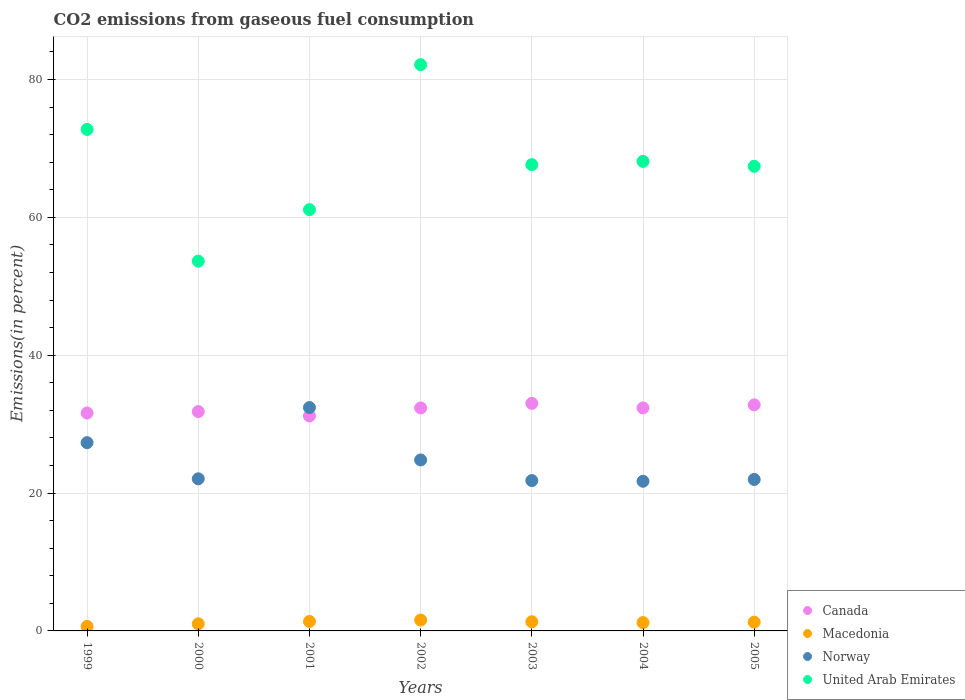How many different coloured dotlines are there?
Offer a very short reply. 4. Is the number of dotlines equal to the number of legend labels?
Keep it short and to the point. Yes. What is the total CO2 emitted in Canada in 2003?
Offer a very short reply. 33.01. Across all years, what is the maximum total CO2 emitted in Norway?
Keep it short and to the point. 32.41. Across all years, what is the minimum total CO2 emitted in Norway?
Keep it short and to the point. 21.71. In which year was the total CO2 emitted in Macedonia maximum?
Offer a very short reply. 2002. In which year was the total CO2 emitted in Macedonia minimum?
Ensure brevity in your answer.  1999. What is the total total CO2 emitted in Canada in the graph?
Your answer should be compact. 225.12. What is the difference between the total CO2 emitted in Macedonia in 1999 and that in 2005?
Make the answer very short. -0.61. What is the difference between the total CO2 emitted in Norway in 2003 and the total CO2 emitted in United Arab Emirates in 1999?
Offer a terse response. -50.95. What is the average total CO2 emitted in Canada per year?
Provide a short and direct response. 32.16. In the year 1999, what is the difference between the total CO2 emitted in Macedonia and total CO2 emitted in United Arab Emirates?
Offer a very short reply. -72.1. In how many years, is the total CO2 emitted in Canada greater than 68 %?
Offer a terse response. 0. What is the ratio of the total CO2 emitted in Macedonia in 1999 to that in 2000?
Keep it short and to the point. 0.64. What is the difference between the highest and the second highest total CO2 emitted in Norway?
Your answer should be very brief. 5.1. What is the difference between the highest and the lowest total CO2 emitted in Canada?
Your answer should be compact. 1.83. In how many years, is the total CO2 emitted in Canada greater than the average total CO2 emitted in Canada taken over all years?
Provide a short and direct response. 4. Is the sum of the total CO2 emitted in United Arab Emirates in 1999 and 2003 greater than the maximum total CO2 emitted in Norway across all years?
Keep it short and to the point. Yes. Is it the case that in every year, the sum of the total CO2 emitted in Norway and total CO2 emitted in Canada  is greater than the sum of total CO2 emitted in Macedonia and total CO2 emitted in United Arab Emirates?
Your response must be concise. No. Is the total CO2 emitted in Canada strictly greater than the total CO2 emitted in Macedonia over the years?
Offer a very short reply. Yes. How many years are there in the graph?
Make the answer very short. 7. Are the values on the major ticks of Y-axis written in scientific E-notation?
Provide a short and direct response. No. Where does the legend appear in the graph?
Offer a very short reply. Bottom right. How many legend labels are there?
Offer a very short reply. 4. What is the title of the graph?
Your response must be concise. CO2 emissions from gaseous fuel consumption. What is the label or title of the Y-axis?
Offer a very short reply. Emissions(in percent). What is the Emissions(in percent) of Canada in 1999?
Offer a terse response. 31.61. What is the Emissions(in percent) in Macedonia in 1999?
Offer a terse response. 0.66. What is the Emissions(in percent) of Norway in 1999?
Offer a very short reply. 27.31. What is the Emissions(in percent) in United Arab Emirates in 1999?
Ensure brevity in your answer.  72.76. What is the Emissions(in percent) of Canada in 2000?
Your response must be concise. 31.82. What is the Emissions(in percent) in Macedonia in 2000?
Make the answer very short. 1.03. What is the Emissions(in percent) in Norway in 2000?
Offer a terse response. 22.07. What is the Emissions(in percent) in United Arab Emirates in 2000?
Offer a very short reply. 53.64. What is the Emissions(in percent) of Canada in 2001?
Your answer should be very brief. 31.18. What is the Emissions(in percent) of Macedonia in 2001?
Offer a very short reply. 1.38. What is the Emissions(in percent) in Norway in 2001?
Your answer should be compact. 32.41. What is the Emissions(in percent) in United Arab Emirates in 2001?
Give a very brief answer. 61.12. What is the Emissions(in percent) of Canada in 2002?
Keep it short and to the point. 32.35. What is the Emissions(in percent) of Macedonia in 2002?
Your answer should be very brief. 1.58. What is the Emissions(in percent) of Norway in 2002?
Provide a short and direct response. 24.8. What is the Emissions(in percent) in United Arab Emirates in 2002?
Your answer should be compact. 82.15. What is the Emissions(in percent) in Canada in 2003?
Offer a terse response. 33.01. What is the Emissions(in percent) in Macedonia in 2003?
Keep it short and to the point. 1.33. What is the Emissions(in percent) in Norway in 2003?
Offer a terse response. 21.81. What is the Emissions(in percent) in United Arab Emirates in 2003?
Your answer should be very brief. 67.64. What is the Emissions(in percent) in Canada in 2004?
Your answer should be compact. 32.35. What is the Emissions(in percent) in Macedonia in 2004?
Offer a very short reply. 1.21. What is the Emissions(in percent) of Norway in 2004?
Your response must be concise. 21.71. What is the Emissions(in percent) in United Arab Emirates in 2004?
Your answer should be compact. 68.12. What is the Emissions(in percent) in Canada in 2005?
Your response must be concise. 32.79. What is the Emissions(in percent) of Macedonia in 2005?
Offer a terse response. 1.27. What is the Emissions(in percent) of Norway in 2005?
Your answer should be very brief. 21.97. What is the Emissions(in percent) of United Arab Emirates in 2005?
Your response must be concise. 67.41. Across all years, what is the maximum Emissions(in percent) in Canada?
Provide a short and direct response. 33.01. Across all years, what is the maximum Emissions(in percent) in Macedonia?
Ensure brevity in your answer.  1.58. Across all years, what is the maximum Emissions(in percent) of Norway?
Ensure brevity in your answer.  32.41. Across all years, what is the maximum Emissions(in percent) in United Arab Emirates?
Your response must be concise. 82.15. Across all years, what is the minimum Emissions(in percent) of Canada?
Keep it short and to the point. 31.18. Across all years, what is the minimum Emissions(in percent) of Macedonia?
Ensure brevity in your answer.  0.66. Across all years, what is the minimum Emissions(in percent) in Norway?
Provide a short and direct response. 21.71. Across all years, what is the minimum Emissions(in percent) of United Arab Emirates?
Your answer should be compact. 53.64. What is the total Emissions(in percent) in Canada in the graph?
Ensure brevity in your answer.  225.12. What is the total Emissions(in percent) of Macedonia in the graph?
Your response must be concise. 8.45. What is the total Emissions(in percent) in Norway in the graph?
Ensure brevity in your answer.  172.09. What is the total Emissions(in percent) of United Arab Emirates in the graph?
Keep it short and to the point. 472.84. What is the difference between the Emissions(in percent) in Canada in 1999 and that in 2000?
Your answer should be compact. -0.21. What is the difference between the Emissions(in percent) in Macedonia in 1999 and that in 2000?
Offer a terse response. -0.38. What is the difference between the Emissions(in percent) in Norway in 1999 and that in 2000?
Make the answer very short. 5.24. What is the difference between the Emissions(in percent) in United Arab Emirates in 1999 and that in 2000?
Your answer should be very brief. 19.12. What is the difference between the Emissions(in percent) in Canada in 1999 and that in 2001?
Give a very brief answer. 0.43. What is the difference between the Emissions(in percent) in Macedonia in 1999 and that in 2001?
Ensure brevity in your answer.  -0.72. What is the difference between the Emissions(in percent) of Norway in 1999 and that in 2001?
Your answer should be compact. -5.1. What is the difference between the Emissions(in percent) in United Arab Emirates in 1999 and that in 2001?
Give a very brief answer. 11.64. What is the difference between the Emissions(in percent) of Canada in 1999 and that in 2002?
Your response must be concise. -0.74. What is the difference between the Emissions(in percent) of Macedonia in 1999 and that in 2002?
Ensure brevity in your answer.  -0.92. What is the difference between the Emissions(in percent) in Norway in 1999 and that in 2002?
Your answer should be compact. 2.51. What is the difference between the Emissions(in percent) of United Arab Emirates in 1999 and that in 2002?
Ensure brevity in your answer.  -9.39. What is the difference between the Emissions(in percent) of Canada in 1999 and that in 2003?
Your answer should be very brief. -1.4. What is the difference between the Emissions(in percent) in Macedonia in 1999 and that in 2003?
Your answer should be compact. -0.67. What is the difference between the Emissions(in percent) of Norway in 1999 and that in 2003?
Provide a short and direct response. 5.5. What is the difference between the Emissions(in percent) in United Arab Emirates in 1999 and that in 2003?
Offer a terse response. 5.12. What is the difference between the Emissions(in percent) in Canada in 1999 and that in 2004?
Your response must be concise. -0.74. What is the difference between the Emissions(in percent) in Macedonia in 1999 and that in 2004?
Give a very brief answer. -0.56. What is the difference between the Emissions(in percent) of Norway in 1999 and that in 2004?
Your answer should be very brief. 5.6. What is the difference between the Emissions(in percent) of United Arab Emirates in 1999 and that in 2004?
Your answer should be very brief. 4.64. What is the difference between the Emissions(in percent) of Canada in 1999 and that in 2005?
Offer a terse response. -1.18. What is the difference between the Emissions(in percent) of Macedonia in 1999 and that in 2005?
Provide a succinct answer. -0.61. What is the difference between the Emissions(in percent) of Norway in 1999 and that in 2005?
Offer a terse response. 5.34. What is the difference between the Emissions(in percent) of United Arab Emirates in 1999 and that in 2005?
Provide a succinct answer. 5.35. What is the difference between the Emissions(in percent) of Canada in 2000 and that in 2001?
Your response must be concise. 0.64. What is the difference between the Emissions(in percent) in Macedonia in 2000 and that in 2001?
Make the answer very short. -0.34. What is the difference between the Emissions(in percent) in Norway in 2000 and that in 2001?
Offer a very short reply. -10.34. What is the difference between the Emissions(in percent) of United Arab Emirates in 2000 and that in 2001?
Your answer should be compact. -7.47. What is the difference between the Emissions(in percent) in Canada in 2000 and that in 2002?
Your response must be concise. -0.53. What is the difference between the Emissions(in percent) of Macedonia in 2000 and that in 2002?
Your answer should be compact. -0.54. What is the difference between the Emissions(in percent) in Norway in 2000 and that in 2002?
Offer a terse response. -2.73. What is the difference between the Emissions(in percent) of United Arab Emirates in 2000 and that in 2002?
Provide a succinct answer. -28.51. What is the difference between the Emissions(in percent) of Canada in 2000 and that in 2003?
Provide a succinct answer. -1.19. What is the difference between the Emissions(in percent) of Macedonia in 2000 and that in 2003?
Keep it short and to the point. -0.3. What is the difference between the Emissions(in percent) of Norway in 2000 and that in 2003?
Your answer should be very brief. 0.26. What is the difference between the Emissions(in percent) in United Arab Emirates in 2000 and that in 2003?
Give a very brief answer. -14. What is the difference between the Emissions(in percent) in Canada in 2000 and that in 2004?
Your response must be concise. -0.53. What is the difference between the Emissions(in percent) of Macedonia in 2000 and that in 2004?
Your answer should be compact. -0.18. What is the difference between the Emissions(in percent) in Norway in 2000 and that in 2004?
Your response must be concise. 0.36. What is the difference between the Emissions(in percent) in United Arab Emirates in 2000 and that in 2004?
Your answer should be compact. -14.48. What is the difference between the Emissions(in percent) of Canada in 2000 and that in 2005?
Ensure brevity in your answer.  -0.97. What is the difference between the Emissions(in percent) in Macedonia in 2000 and that in 2005?
Your answer should be very brief. -0.23. What is the difference between the Emissions(in percent) in Norway in 2000 and that in 2005?
Your response must be concise. 0.1. What is the difference between the Emissions(in percent) in United Arab Emirates in 2000 and that in 2005?
Provide a short and direct response. -13.76. What is the difference between the Emissions(in percent) in Canada in 2001 and that in 2002?
Your answer should be very brief. -1.16. What is the difference between the Emissions(in percent) in Macedonia in 2001 and that in 2002?
Your response must be concise. -0.2. What is the difference between the Emissions(in percent) in Norway in 2001 and that in 2002?
Provide a short and direct response. 7.61. What is the difference between the Emissions(in percent) of United Arab Emirates in 2001 and that in 2002?
Offer a terse response. -21.04. What is the difference between the Emissions(in percent) of Canada in 2001 and that in 2003?
Ensure brevity in your answer.  -1.83. What is the difference between the Emissions(in percent) in Macedonia in 2001 and that in 2003?
Your response must be concise. 0.05. What is the difference between the Emissions(in percent) of Norway in 2001 and that in 2003?
Your answer should be very brief. 10.6. What is the difference between the Emissions(in percent) of United Arab Emirates in 2001 and that in 2003?
Your response must be concise. -6.53. What is the difference between the Emissions(in percent) in Canada in 2001 and that in 2004?
Provide a succinct answer. -1.17. What is the difference between the Emissions(in percent) in Macedonia in 2001 and that in 2004?
Ensure brevity in your answer.  0.16. What is the difference between the Emissions(in percent) in Norway in 2001 and that in 2004?
Your answer should be very brief. 10.7. What is the difference between the Emissions(in percent) in United Arab Emirates in 2001 and that in 2004?
Provide a succinct answer. -7. What is the difference between the Emissions(in percent) of Canada in 2001 and that in 2005?
Offer a terse response. -1.61. What is the difference between the Emissions(in percent) in Macedonia in 2001 and that in 2005?
Offer a terse response. 0.11. What is the difference between the Emissions(in percent) in Norway in 2001 and that in 2005?
Provide a succinct answer. 10.44. What is the difference between the Emissions(in percent) of United Arab Emirates in 2001 and that in 2005?
Your response must be concise. -6.29. What is the difference between the Emissions(in percent) in Canada in 2002 and that in 2003?
Make the answer very short. -0.66. What is the difference between the Emissions(in percent) of Macedonia in 2002 and that in 2003?
Ensure brevity in your answer.  0.25. What is the difference between the Emissions(in percent) of Norway in 2002 and that in 2003?
Give a very brief answer. 2.99. What is the difference between the Emissions(in percent) of United Arab Emirates in 2002 and that in 2003?
Keep it short and to the point. 14.51. What is the difference between the Emissions(in percent) of Canada in 2002 and that in 2004?
Offer a terse response. -0.01. What is the difference between the Emissions(in percent) of Macedonia in 2002 and that in 2004?
Ensure brevity in your answer.  0.36. What is the difference between the Emissions(in percent) of Norway in 2002 and that in 2004?
Provide a succinct answer. 3.09. What is the difference between the Emissions(in percent) in United Arab Emirates in 2002 and that in 2004?
Provide a short and direct response. 14.03. What is the difference between the Emissions(in percent) of Canada in 2002 and that in 2005?
Offer a very short reply. -0.45. What is the difference between the Emissions(in percent) in Macedonia in 2002 and that in 2005?
Make the answer very short. 0.31. What is the difference between the Emissions(in percent) of Norway in 2002 and that in 2005?
Make the answer very short. 2.83. What is the difference between the Emissions(in percent) in United Arab Emirates in 2002 and that in 2005?
Make the answer very short. 14.75. What is the difference between the Emissions(in percent) of Canada in 2003 and that in 2004?
Your response must be concise. 0.66. What is the difference between the Emissions(in percent) in Macedonia in 2003 and that in 2004?
Provide a succinct answer. 0.12. What is the difference between the Emissions(in percent) of Norway in 2003 and that in 2004?
Your answer should be compact. 0.1. What is the difference between the Emissions(in percent) of United Arab Emirates in 2003 and that in 2004?
Offer a terse response. -0.47. What is the difference between the Emissions(in percent) of Canada in 2003 and that in 2005?
Offer a very short reply. 0.22. What is the difference between the Emissions(in percent) in Macedonia in 2003 and that in 2005?
Offer a very short reply. 0.06. What is the difference between the Emissions(in percent) in Norway in 2003 and that in 2005?
Give a very brief answer. -0.16. What is the difference between the Emissions(in percent) of United Arab Emirates in 2003 and that in 2005?
Give a very brief answer. 0.24. What is the difference between the Emissions(in percent) of Canada in 2004 and that in 2005?
Your answer should be very brief. -0.44. What is the difference between the Emissions(in percent) in Macedonia in 2004 and that in 2005?
Give a very brief answer. -0.06. What is the difference between the Emissions(in percent) in Norway in 2004 and that in 2005?
Your response must be concise. -0.26. What is the difference between the Emissions(in percent) in United Arab Emirates in 2004 and that in 2005?
Provide a short and direct response. 0.71. What is the difference between the Emissions(in percent) in Canada in 1999 and the Emissions(in percent) in Macedonia in 2000?
Provide a succinct answer. 30.58. What is the difference between the Emissions(in percent) of Canada in 1999 and the Emissions(in percent) of Norway in 2000?
Offer a very short reply. 9.54. What is the difference between the Emissions(in percent) of Canada in 1999 and the Emissions(in percent) of United Arab Emirates in 2000?
Provide a succinct answer. -22.03. What is the difference between the Emissions(in percent) of Macedonia in 1999 and the Emissions(in percent) of Norway in 2000?
Offer a very short reply. -21.41. What is the difference between the Emissions(in percent) in Macedonia in 1999 and the Emissions(in percent) in United Arab Emirates in 2000?
Give a very brief answer. -52.99. What is the difference between the Emissions(in percent) in Norway in 1999 and the Emissions(in percent) in United Arab Emirates in 2000?
Provide a short and direct response. -26.33. What is the difference between the Emissions(in percent) in Canada in 1999 and the Emissions(in percent) in Macedonia in 2001?
Provide a succinct answer. 30.24. What is the difference between the Emissions(in percent) of Canada in 1999 and the Emissions(in percent) of Norway in 2001?
Offer a very short reply. -0.8. What is the difference between the Emissions(in percent) in Canada in 1999 and the Emissions(in percent) in United Arab Emirates in 2001?
Provide a short and direct response. -29.5. What is the difference between the Emissions(in percent) in Macedonia in 1999 and the Emissions(in percent) in Norway in 2001?
Your answer should be very brief. -31.75. What is the difference between the Emissions(in percent) of Macedonia in 1999 and the Emissions(in percent) of United Arab Emirates in 2001?
Your answer should be compact. -60.46. What is the difference between the Emissions(in percent) of Norway in 1999 and the Emissions(in percent) of United Arab Emirates in 2001?
Provide a short and direct response. -33.8. What is the difference between the Emissions(in percent) in Canada in 1999 and the Emissions(in percent) in Macedonia in 2002?
Offer a terse response. 30.04. What is the difference between the Emissions(in percent) of Canada in 1999 and the Emissions(in percent) of Norway in 2002?
Ensure brevity in your answer.  6.81. What is the difference between the Emissions(in percent) in Canada in 1999 and the Emissions(in percent) in United Arab Emirates in 2002?
Provide a succinct answer. -50.54. What is the difference between the Emissions(in percent) in Macedonia in 1999 and the Emissions(in percent) in Norway in 2002?
Your answer should be compact. -24.15. What is the difference between the Emissions(in percent) in Macedonia in 1999 and the Emissions(in percent) in United Arab Emirates in 2002?
Your response must be concise. -81.49. What is the difference between the Emissions(in percent) in Norway in 1999 and the Emissions(in percent) in United Arab Emirates in 2002?
Your response must be concise. -54.84. What is the difference between the Emissions(in percent) of Canada in 1999 and the Emissions(in percent) of Macedonia in 2003?
Your answer should be compact. 30.28. What is the difference between the Emissions(in percent) of Canada in 1999 and the Emissions(in percent) of Norway in 2003?
Your answer should be very brief. 9.8. What is the difference between the Emissions(in percent) of Canada in 1999 and the Emissions(in percent) of United Arab Emirates in 2003?
Your response must be concise. -36.03. What is the difference between the Emissions(in percent) of Macedonia in 1999 and the Emissions(in percent) of Norway in 2003?
Ensure brevity in your answer.  -21.16. What is the difference between the Emissions(in percent) of Macedonia in 1999 and the Emissions(in percent) of United Arab Emirates in 2003?
Offer a very short reply. -66.99. What is the difference between the Emissions(in percent) in Norway in 1999 and the Emissions(in percent) in United Arab Emirates in 2003?
Provide a short and direct response. -40.33. What is the difference between the Emissions(in percent) in Canada in 1999 and the Emissions(in percent) in Macedonia in 2004?
Give a very brief answer. 30.4. What is the difference between the Emissions(in percent) of Canada in 1999 and the Emissions(in percent) of Norway in 2004?
Offer a terse response. 9.9. What is the difference between the Emissions(in percent) of Canada in 1999 and the Emissions(in percent) of United Arab Emirates in 2004?
Offer a very short reply. -36.51. What is the difference between the Emissions(in percent) of Macedonia in 1999 and the Emissions(in percent) of Norway in 2004?
Ensure brevity in your answer.  -21.05. What is the difference between the Emissions(in percent) in Macedonia in 1999 and the Emissions(in percent) in United Arab Emirates in 2004?
Your answer should be compact. -67.46. What is the difference between the Emissions(in percent) of Norway in 1999 and the Emissions(in percent) of United Arab Emirates in 2004?
Provide a short and direct response. -40.81. What is the difference between the Emissions(in percent) of Canada in 1999 and the Emissions(in percent) of Macedonia in 2005?
Offer a terse response. 30.34. What is the difference between the Emissions(in percent) in Canada in 1999 and the Emissions(in percent) in Norway in 2005?
Your response must be concise. 9.64. What is the difference between the Emissions(in percent) in Canada in 1999 and the Emissions(in percent) in United Arab Emirates in 2005?
Your response must be concise. -35.79. What is the difference between the Emissions(in percent) in Macedonia in 1999 and the Emissions(in percent) in Norway in 2005?
Ensure brevity in your answer.  -21.32. What is the difference between the Emissions(in percent) in Macedonia in 1999 and the Emissions(in percent) in United Arab Emirates in 2005?
Provide a succinct answer. -66.75. What is the difference between the Emissions(in percent) of Norway in 1999 and the Emissions(in percent) of United Arab Emirates in 2005?
Give a very brief answer. -40.09. What is the difference between the Emissions(in percent) in Canada in 2000 and the Emissions(in percent) in Macedonia in 2001?
Provide a short and direct response. 30.45. What is the difference between the Emissions(in percent) of Canada in 2000 and the Emissions(in percent) of Norway in 2001?
Offer a terse response. -0.59. What is the difference between the Emissions(in percent) of Canada in 2000 and the Emissions(in percent) of United Arab Emirates in 2001?
Give a very brief answer. -29.29. What is the difference between the Emissions(in percent) of Macedonia in 2000 and the Emissions(in percent) of Norway in 2001?
Give a very brief answer. -31.38. What is the difference between the Emissions(in percent) of Macedonia in 2000 and the Emissions(in percent) of United Arab Emirates in 2001?
Ensure brevity in your answer.  -60.08. What is the difference between the Emissions(in percent) of Norway in 2000 and the Emissions(in percent) of United Arab Emirates in 2001?
Provide a short and direct response. -39.05. What is the difference between the Emissions(in percent) in Canada in 2000 and the Emissions(in percent) in Macedonia in 2002?
Offer a very short reply. 30.24. What is the difference between the Emissions(in percent) of Canada in 2000 and the Emissions(in percent) of Norway in 2002?
Your answer should be very brief. 7.02. What is the difference between the Emissions(in percent) in Canada in 2000 and the Emissions(in percent) in United Arab Emirates in 2002?
Ensure brevity in your answer.  -50.33. What is the difference between the Emissions(in percent) in Macedonia in 2000 and the Emissions(in percent) in Norway in 2002?
Make the answer very short. -23.77. What is the difference between the Emissions(in percent) in Macedonia in 2000 and the Emissions(in percent) in United Arab Emirates in 2002?
Your answer should be very brief. -81.12. What is the difference between the Emissions(in percent) in Norway in 2000 and the Emissions(in percent) in United Arab Emirates in 2002?
Offer a very short reply. -60.08. What is the difference between the Emissions(in percent) in Canada in 2000 and the Emissions(in percent) in Macedonia in 2003?
Provide a succinct answer. 30.49. What is the difference between the Emissions(in percent) of Canada in 2000 and the Emissions(in percent) of Norway in 2003?
Ensure brevity in your answer.  10.01. What is the difference between the Emissions(in percent) of Canada in 2000 and the Emissions(in percent) of United Arab Emirates in 2003?
Your response must be concise. -35.82. What is the difference between the Emissions(in percent) of Macedonia in 2000 and the Emissions(in percent) of Norway in 2003?
Your answer should be very brief. -20.78. What is the difference between the Emissions(in percent) in Macedonia in 2000 and the Emissions(in percent) in United Arab Emirates in 2003?
Your response must be concise. -66.61. What is the difference between the Emissions(in percent) in Norway in 2000 and the Emissions(in percent) in United Arab Emirates in 2003?
Keep it short and to the point. -45.58. What is the difference between the Emissions(in percent) of Canada in 2000 and the Emissions(in percent) of Macedonia in 2004?
Your answer should be compact. 30.61. What is the difference between the Emissions(in percent) in Canada in 2000 and the Emissions(in percent) in Norway in 2004?
Your answer should be very brief. 10.11. What is the difference between the Emissions(in percent) of Canada in 2000 and the Emissions(in percent) of United Arab Emirates in 2004?
Offer a terse response. -36.3. What is the difference between the Emissions(in percent) in Macedonia in 2000 and the Emissions(in percent) in Norway in 2004?
Offer a very short reply. -20.68. What is the difference between the Emissions(in percent) of Macedonia in 2000 and the Emissions(in percent) of United Arab Emirates in 2004?
Give a very brief answer. -67.09. What is the difference between the Emissions(in percent) of Norway in 2000 and the Emissions(in percent) of United Arab Emirates in 2004?
Your answer should be compact. -46.05. What is the difference between the Emissions(in percent) of Canada in 2000 and the Emissions(in percent) of Macedonia in 2005?
Your answer should be very brief. 30.55. What is the difference between the Emissions(in percent) of Canada in 2000 and the Emissions(in percent) of Norway in 2005?
Give a very brief answer. 9.85. What is the difference between the Emissions(in percent) of Canada in 2000 and the Emissions(in percent) of United Arab Emirates in 2005?
Ensure brevity in your answer.  -35.58. What is the difference between the Emissions(in percent) of Macedonia in 2000 and the Emissions(in percent) of Norway in 2005?
Your answer should be compact. -20.94. What is the difference between the Emissions(in percent) of Macedonia in 2000 and the Emissions(in percent) of United Arab Emirates in 2005?
Your answer should be compact. -66.37. What is the difference between the Emissions(in percent) in Norway in 2000 and the Emissions(in percent) in United Arab Emirates in 2005?
Offer a terse response. -45.34. What is the difference between the Emissions(in percent) of Canada in 2001 and the Emissions(in percent) of Macedonia in 2002?
Give a very brief answer. 29.61. What is the difference between the Emissions(in percent) in Canada in 2001 and the Emissions(in percent) in Norway in 2002?
Provide a short and direct response. 6.38. What is the difference between the Emissions(in percent) in Canada in 2001 and the Emissions(in percent) in United Arab Emirates in 2002?
Ensure brevity in your answer.  -50.97. What is the difference between the Emissions(in percent) of Macedonia in 2001 and the Emissions(in percent) of Norway in 2002?
Ensure brevity in your answer.  -23.43. What is the difference between the Emissions(in percent) in Macedonia in 2001 and the Emissions(in percent) in United Arab Emirates in 2002?
Give a very brief answer. -80.78. What is the difference between the Emissions(in percent) in Norway in 2001 and the Emissions(in percent) in United Arab Emirates in 2002?
Your answer should be compact. -49.74. What is the difference between the Emissions(in percent) in Canada in 2001 and the Emissions(in percent) in Macedonia in 2003?
Provide a succinct answer. 29.85. What is the difference between the Emissions(in percent) of Canada in 2001 and the Emissions(in percent) of Norway in 2003?
Make the answer very short. 9.37. What is the difference between the Emissions(in percent) in Canada in 2001 and the Emissions(in percent) in United Arab Emirates in 2003?
Offer a terse response. -36.46. What is the difference between the Emissions(in percent) of Macedonia in 2001 and the Emissions(in percent) of Norway in 2003?
Offer a very short reply. -20.44. What is the difference between the Emissions(in percent) in Macedonia in 2001 and the Emissions(in percent) in United Arab Emirates in 2003?
Ensure brevity in your answer.  -66.27. What is the difference between the Emissions(in percent) of Norway in 2001 and the Emissions(in percent) of United Arab Emirates in 2003?
Offer a very short reply. -35.24. What is the difference between the Emissions(in percent) of Canada in 2001 and the Emissions(in percent) of Macedonia in 2004?
Keep it short and to the point. 29.97. What is the difference between the Emissions(in percent) of Canada in 2001 and the Emissions(in percent) of Norway in 2004?
Offer a terse response. 9.47. What is the difference between the Emissions(in percent) of Canada in 2001 and the Emissions(in percent) of United Arab Emirates in 2004?
Make the answer very short. -36.94. What is the difference between the Emissions(in percent) of Macedonia in 2001 and the Emissions(in percent) of Norway in 2004?
Offer a very short reply. -20.34. What is the difference between the Emissions(in percent) of Macedonia in 2001 and the Emissions(in percent) of United Arab Emirates in 2004?
Offer a very short reply. -66.74. What is the difference between the Emissions(in percent) in Norway in 2001 and the Emissions(in percent) in United Arab Emirates in 2004?
Your answer should be compact. -35.71. What is the difference between the Emissions(in percent) of Canada in 2001 and the Emissions(in percent) of Macedonia in 2005?
Keep it short and to the point. 29.92. What is the difference between the Emissions(in percent) of Canada in 2001 and the Emissions(in percent) of Norway in 2005?
Your response must be concise. 9.21. What is the difference between the Emissions(in percent) of Canada in 2001 and the Emissions(in percent) of United Arab Emirates in 2005?
Provide a short and direct response. -36.22. What is the difference between the Emissions(in percent) of Macedonia in 2001 and the Emissions(in percent) of Norway in 2005?
Provide a succinct answer. -20.6. What is the difference between the Emissions(in percent) in Macedonia in 2001 and the Emissions(in percent) in United Arab Emirates in 2005?
Offer a terse response. -66.03. What is the difference between the Emissions(in percent) of Norway in 2001 and the Emissions(in percent) of United Arab Emirates in 2005?
Your response must be concise. -35. What is the difference between the Emissions(in percent) of Canada in 2002 and the Emissions(in percent) of Macedonia in 2003?
Provide a short and direct response. 31.02. What is the difference between the Emissions(in percent) in Canada in 2002 and the Emissions(in percent) in Norway in 2003?
Make the answer very short. 10.53. What is the difference between the Emissions(in percent) of Canada in 2002 and the Emissions(in percent) of United Arab Emirates in 2003?
Give a very brief answer. -35.3. What is the difference between the Emissions(in percent) in Macedonia in 2002 and the Emissions(in percent) in Norway in 2003?
Give a very brief answer. -20.24. What is the difference between the Emissions(in percent) in Macedonia in 2002 and the Emissions(in percent) in United Arab Emirates in 2003?
Your response must be concise. -66.07. What is the difference between the Emissions(in percent) of Norway in 2002 and the Emissions(in percent) of United Arab Emirates in 2003?
Provide a short and direct response. -42.84. What is the difference between the Emissions(in percent) in Canada in 2002 and the Emissions(in percent) in Macedonia in 2004?
Your response must be concise. 31.14. What is the difference between the Emissions(in percent) in Canada in 2002 and the Emissions(in percent) in Norway in 2004?
Offer a terse response. 10.64. What is the difference between the Emissions(in percent) in Canada in 2002 and the Emissions(in percent) in United Arab Emirates in 2004?
Provide a succinct answer. -35.77. What is the difference between the Emissions(in percent) of Macedonia in 2002 and the Emissions(in percent) of Norway in 2004?
Make the answer very short. -20.14. What is the difference between the Emissions(in percent) of Macedonia in 2002 and the Emissions(in percent) of United Arab Emirates in 2004?
Keep it short and to the point. -66.54. What is the difference between the Emissions(in percent) of Norway in 2002 and the Emissions(in percent) of United Arab Emirates in 2004?
Make the answer very short. -43.32. What is the difference between the Emissions(in percent) in Canada in 2002 and the Emissions(in percent) in Macedonia in 2005?
Keep it short and to the point. 31.08. What is the difference between the Emissions(in percent) in Canada in 2002 and the Emissions(in percent) in Norway in 2005?
Provide a succinct answer. 10.37. What is the difference between the Emissions(in percent) in Canada in 2002 and the Emissions(in percent) in United Arab Emirates in 2005?
Make the answer very short. -35.06. What is the difference between the Emissions(in percent) in Macedonia in 2002 and the Emissions(in percent) in Norway in 2005?
Your response must be concise. -20.4. What is the difference between the Emissions(in percent) in Macedonia in 2002 and the Emissions(in percent) in United Arab Emirates in 2005?
Keep it short and to the point. -65.83. What is the difference between the Emissions(in percent) of Norway in 2002 and the Emissions(in percent) of United Arab Emirates in 2005?
Your answer should be compact. -42.6. What is the difference between the Emissions(in percent) of Canada in 2003 and the Emissions(in percent) of Macedonia in 2004?
Your response must be concise. 31.8. What is the difference between the Emissions(in percent) of Canada in 2003 and the Emissions(in percent) of Norway in 2004?
Ensure brevity in your answer.  11.3. What is the difference between the Emissions(in percent) in Canada in 2003 and the Emissions(in percent) in United Arab Emirates in 2004?
Make the answer very short. -35.11. What is the difference between the Emissions(in percent) of Macedonia in 2003 and the Emissions(in percent) of Norway in 2004?
Provide a succinct answer. -20.38. What is the difference between the Emissions(in percent) of Macedonia in 2003 and the Emissions(in percent) of United Arab Emirates in 2004?
Ensure brevity in your answer.  -66.79. What is the difference between the Emissions(in percent) in Norway in 2003 and the Emissions(in percent) in United Arab Emirates in 2004?
Offer a terse response. -46.31. What is the difference between the Emissions(in percent) of Canada in 2003 and the Emissions(in percent) of Macedonia in 2005?
Offer a very short reply. 31.74. What is the difference between the Emissions(in percent) of Canada in 2003 and the Emissions(in percent) of Norway in 2005?
Keep it short and to the point. 11.04. What is the difference between the Emissions(in percent) in Canada in 2003 and the Emissions(in percent) in United Arab Emirates in 2005?
Provide a succinct answer. -34.4. What is the difference between the Emissions(in percent) in Macedonia in 2003 and the Emissions(in percent) in Norway in 2005?
Keep it short and to the point. -20.64. What is the difference between the Emissions(in percent) of Macedonia in 2003 and the Emissions(in percent) of United Arab Emirates in 2005?
Your answer should be compact. -66.08. What is the difference between the Emissions(in percent) in Norway in 2003 and the Emissions(in percent) in United Arab Emirates in 2005?
Offer a terse response. -45.59. What is the difference between the Emissions(in percent) in Canada in 2004 and the Emissions(in percent) in Macedonia in 2005?
Offer a very short reply. 31.09. What is the difference between the Emissions(in percent) of Canada in 2004 and the Emissions(in percent) of Norway in 2005?
Your response must be concise. 10.38. What is the difference between the Emissions(in percent) of Canada in 2004 and the Emissions(in percent) of United Arab Emirates in 2005?
Give a very brief answer. -35.05. What is the difference between the Emissions(in percent) of Macedonia in 2004 and the Emissions(in percent) of Norway in 2005?
Give a very brief answer. -20.76. What is the difference between the Emissions(in percent) of Macedonia in 2004 and the Emissions(in percent) of United Arab Emirates in 2005?
Provide a succinct answer. -66.19. What is the difference between the Emissions(in percent) in Norway in 2004 and the Emissions(in percent) in United Arab Emirates in 2005?
Ensure brevity in your answer.  -45.69. What is the average Emissions(in percent) of Canada per year?
Provide a succinct answer. 32.16. What is the average Emissions(in percent) of Macedonia per year?
Keep it short and to the point. 1.21. What is the average Emissions(in percent) of Norway per year?
Keep it short and to the point. 24.58. What is the average Emissions(in percent) in United Arab Emirates per year?
Keep it short and to the point. 67.55. In the year 1999, what is the difference between the Emissions(in percent) in Canada and Emissions(in percent) in Macedonia?
Make the answer very short. 30.95. In the year 1999, what is the difference between the Emissions(in percent) in Canada and Emissions(in percent) in Norway?
Make the answer very short. 4.3. In the year 1999, what is the difference between the Emissions(in percent) in Canada and Emissions(in percent) in United Arab Emirates?
Offer a very short reply. -41.15. In the year 1999, what is the difference between the Emissions(in percent) in Macedonia and Emissions(in percent) in Norway?
Your answer should be very brief. -26.65. In the year 1999, what is the difference between the Emissions(in percent) of Macedonia and Emissions(in percent) of United Arab Emirates?
Offer a terse response. -72.1. In the year 1999, what is the difference between the Emissions(in percent) in Norway and Emissions(in percent) in United Arab Emirates?
Offer a terse response. -45.45. In the year 2000, what is the difference between the Emissions(in percent) in Canada and Emissions(in percent) in Macedonia?
Give a very brief answer. 30.79. In the year 2000, what is the difference between the Emissions(in percent) in Canada and Emissions(in percent) in Norway?
Make the answer very short. 9.75. In the year 2000, what is the difference between the Emissions(in percent) of Canada and Emissions(in percent) of United Arab Emirates?
Your answer should be compact. -21.82. In the year 2000, what is the difference between the Emissions(in percent) of Macedonia and Emissions(in percent) of Norway?
Provide a short and direct response. -21.04. In the year 2000, what is the difference between the Emissions(in percent) of Macedonia and Emissions(in percent) of United Arab Emirates?
Offer a terse response. -52.61. In the year 2000, what is the difference between the Emissions(in percent) of Norway and Emissions(in percent) of United Arab Emirates?
Your answer should be very brief. -31.57. In the year 2001, what is the difference between the Emissions(in percent) in Canada and Emissions(in percent) in Macedonia?
Your answer should be very brief. 29.81. In the year 2001, what is the difference between the Emissions(in percent) of Canada and Emissions(in percent) of Norway?
Offer a terse response. -1.23. In the year 2001, what is the difference between the Emissions(in percent) in Canada and Emissions(in percent) in United Arab Emirates?
Keep it short and to the point. -29.93. In the year 2001, what is the difference between the Emissions(in percent) of Macedonia and Emissions(in percent) of Norway?
Give a very brief answer. -31.03. In the year 2001, what is the difference between the Emissions(in percent) of Macedonia and Emissions(in percent) of United Arab Emirates?
Keep it short and to the point. -59.74. In the year 2001, what is the difference between the Emissions(in percent) of Norway and Emissions(in percent) of United Arab Emirates?
Your answer should be very brief. -28.71. In the year 2002, what is the difference between the Emissions(in percent) of Canada and Emissions(in percent) of Macedonia?
Your answer should be very brief. 30.77. In the year 2002, what is the difference between the Emissions(in percent) of Canada and Emissions(in percent) of Norway?
Offer a terse response. 7.55. In the year 2002, what is the difference between the Emissions(in percent) in Canada and Emissions(in percent) in United Arab Emirates?
Ensure brevity in your answer.  -49.8. In the year 2002, what is the difference between the Emissions(in percent) of Macedonia and Emissions(in percent) of Norway?
Ensure brevity in your answer.  -23.23. In the year 2002, what is the difference between the Emissions(in percent) of Macedonia and Emissions(in percent) of United Arab Emirates?
Your response must be concise. -80.57. In the year 2002, what is the difference between the Emissions(in percent) in Norway and Emissions(in percent) in United Arab Emirates?
Offer a terse response. -57.35. In the year 2003, what is the difference between the Emissions(in percent) of Canada and Emissions(in percent) of Macedonia?
Your answer should be compact. 31.68. In the year 2003, what is the difference between the Emissions(in percent) in Canada and Emissions(in percent) in Norway?
Make the answer very short. 11.2. In the year 2003, what is the difference between the Emissions(in percent) in Canada and Emissions(in percent) in United Arab Emirates?
Your answer should be compact. -34.63. In the year 2003, what is the difference between the Emissions(in percent) of Macedonia and Emissions(in percent) of Norway?
Ensure brevity in your answer.  -20.48. In the year 2003, what is the difference between the Emissions(in percent) of Macedonia and Emissions(in percent) of United Arab Emirates?
Make the answer very short. -66.32. In the year 2003, what is the difference between the Emissions(in percent) in Norway and Emissions(in percent) in United Arab Emirates?
Offer a very short reply. -45.83. In the year 2004, what is the difference between the Emissions(in percent) of Canada and Emissions(in percent) of Macedonia?
Your answer should be compact. 31.14. In the year 2004, what is the difference between the Emissions(in percent) of Canada and Emissions(in percent) of Norway?
Make the answer very short. 10.64. In the year 2004, what is the difference between the Emissions(in percent) in Canada and Emissions(in percent) in United Arab Emirates?
Offer a very short reply. -35.77. In the year 2004, what is the difference between the Emissions(in percent) in Macedonia and Emissions(in percent) in Norway?
Make the answer very short. -20.5. In the year 2004, what is the difference between the Emissions(in percent) of Macedonia and Emissions(in percent) of United Arab Emirates?
Your answer should be compact. -66.91. In the year 2004, what is the difference between the Emissions(in percent) in Norway and Emissions(in percent) in United Arab Emirates?
Make the answer very short. -46.41. In the year 2005, what is the difference between the Emissions(in percent) in Canada and Emissions(in percent) in Macedonia?
Make the answer very short. 31.53. In the year 2005, what is the difference between the Emissions(in percent) of Canada and Emissions(in percent) of Norway?
Make the answer very short. 10.82. In the year 2005, what is the difference between the Emissions(in percent) in Canada and Emissions(in percent) in United Arab Emirates?
Offer a terse response. -34.61. In the year 2005, what is the difference between the Emissions(in percent) in Macedonia and Emissions(in percent) in Norway?
Provide a short and direct response. -20.71. In the year 2005, what is the difference between the Emissions(in percent) of Macedonia and Emissions(in percent) of United Arab Emirates?
Your answer should be compact. -66.14. In the year 2005, what is the difference between the Emissions(in percent) of Norway and Emissions(in percent) of United Arab Emirates?
Your answer should be compact. -45.43. What is the ratio of the Emissions(in percent) of Canada in 1999 to that in 2000?
Your answer should be very brief. 0.99. What is the ratio of the Emissions(in percent) in Macedonia in 1999 to that in 2000?
Provide a short and direct response. 0.64. What is the ratio of the Emissions(in percent) of Norway in 1999 to that in 2000?
Provide a short and direct response. 1.24. What is the ratio of the Emissions(in percent) in United Arab Emirates in 1999 to that in 2000?
Provide a succinct answer. 1.36. What is the ratio of the Emissions(in percent) in Canada in 1999 to that in 2001?
Give a very brief answer. 1.01. What is the ratio of the Emissions(in percent) in Macedonia in 1999 to that in 2001?
Your response must be concise. 0.48. What is the ratio of the Emissions(in percent) of Norway in 1999 to that in 2001?
Your answer should be very brief. 0.84. What is the ratio of the Emissions(in percent) in United Arab Emirates in 1999 to that in 2001?
Your answer should be very brief. 1.19. What is the ratio of the Emissions(in percent) of Canada in 1999 to that in 2002?
Your answer should be compact. 0.98. What is the ratio of the Emissions(in percent) in Macedonia in 1999 to that in 2002?
Your answer should be compact. 0.42. What is the ratio of the Emissions(in percent) in Norway in 1999 to that in 2002?
Keep it short and to the point. 1.1. What is the ratio of the Emissions(in percent) in United Arab Emirates in 1999 to that in 2002?
Keep it short and to the point. 0.89. What is the ratio of the Emissions(in percent) in Canada in 1999 to that in 2003?
Your answer should be very brief. 0.96. What is the ratio of the Emissions(in percent) of Macedonia in 1999 to that in 2003?
Give a very brief answer. 0.49. What is the ratio of the Emissions(in percent) of Norway in 1999 to that in 2003?
Keep it short and to the point. 1.25. What is the ratio of the Emissions(in percent) in United Arab Emirates in 1999 to that in 2003?
Provide a succinct answer. 1.08. What is the ratio of the Emissions(in percent) in Canada in 1999 to that in 2004?
Keep it short and to the point. 0.98. What is the ratio of the Emissions(in percent) of Macedonia in 1999 to that in 2004?
Your answer should be very brief. 0.54. What is the ratio of the Emissions(in percent) in Norway in 1999 to that in 2004?
Provide a succinct answer. 1.26. What is the ratio of the Emissions(in percent) of United Arab Emirates in 1999 to that in 2004?
Ensure brevity in your answer.  1.07. What is the ratio of the Emissions(in percent) of Canada in 1999 to that in 2005?
Ensure brevity in your answer.  0.96. What is the ratio of the Emissions(in percent) in Macedonia in 1999 to that in 2005?
Offer a very short reply. 0.52. What is the ratio of the Emissions(in percent) in Norway in 1999 to that in 2005?
Provide a short and direct response. 1.24. What is the ratio of the Emissions(in percent) of United Arab Emirates in 1999 to that in 2005?
Keep it short and to the point. 1.08. What is the ratio of the Emissions(in percent) in Canada in 2000 to that in 2001?
Your answer should be very brief. 1.02. What is the ratio of the Emissions(in percent) of Macedonia in 2000 to that in 2001?
Keep it short and to the point. 0.75. What is the ratio of the Emissions(in percent) of Norway in 2000 to that in 2001?
Provide a short and direct response. 0.68. What is the ratio of the Emissions(in percent) in United Arab Emirates in 2000 to that in 2001?
Your answer should be very brief. 0.88. What is the ratio of the Emissions(in percent) of Canada in 2000 to that in 2002?
Offer a very short reply. 0.98. What is the ratio of the Emissions(in percent) in Macedonia in 2000 to that in 2002?
Provide a short and direct response. 0.66. What is the ratio of the Emissions(in percent) in Norway in 2000 to that in 2002?
Offer a terse response. 0.89. What is the ratio of the Emissions(in percent) in United Arab Emirates in 2000 to that in 2002?
Ensure brevity in your answer.  0.65. What is the ratio of the Emissions(in percent) of Macedonia in 2000 to that in 2003?
Ensure brevity in your answer.  0.78. What is the ratio of the Emissions(in percent) in Norway in 2000 to that in 2003?
Provide a short and direct response. 1.01. What is the ratio of the Emissions(in percent) of United Arab Emirates in 2000 to that in 2003?
Your answer should be compact. 0.79. What is the ratio of the Emissions(in percent) in Canada in 2000 to that in 2004?
Make the answer very short. 0.98. What is the ratio of the Emissions(in percent) in Macedonia in 2000 to that in 2004?
Offer a terse response. 0.85. What is the ratio of the Emissions(in percent) in Norway in 2000 to that in 2004?
Your answer should be compact. 1.02. What is the ratio of the Emissions(in percent) of United Arab Emirates in 2000 to that in 2004?
Provide a succinct answer. 0.79. What is the ratio of the Emissions(in percent) of Canada in 2000 to that in 2005?
Offer a very short reply. 0.97. What is the ratio of the Emissions(in percent) of Macedonia in 2000 to that in 2005?
Offer a terse response. 0.82. What is the ratio of the Emissions(in percent) of United Arab Emirates in 2000 to that in 2005?
Provide a short and direct response. 0.8. What is the ratio of the Emissions(in percent) in Canada in 2001 to that in 2002?
Give a very brief answer. 0.96. What is the ratio of the Emissions(in percent) in Macedonia in 2001 to that in 2002?
Offer a very short reply. 0.87. What is the ratio of the Emissions(in percent) of Norway in 2001 to that in 2002?
Offer a very short reply. 1.31. What is the ratio of the Emissions(in percent) of United Arab Emirates in 2001 to that in 2002?
Your answer should be compact. 0.74. What is the ratio of the Emissions(in percent) in Canada in 2001 to that in 2003?
Offer a very short reply. 0.94. What is the ratio of the Emissions(in percent) in Macedonia in 2001 to that in 2003?
Provide a short and direct response. 1.03. What is the ratio of the Emissions(in percent) of Norway in 2001 to that in 2003?
Your answer should be very brief. 1.49. What is the ratio of the Emissions(in percent) in United Arab Emirates in 2001 to that in 2003?
Your answer should be very brief. 0.9. What is the ratio of the Emissions(in percent) in Canada in 2001 to that in 2004?
Make the answer very short. 0.96. What is the ratio of the Emissions(in percent) in Macedonia in 2001 to that in 2004?
Provide a short and direct response. 1.13. What is the ratio of the Emissions(in percent) of Norway in 2001 to that in 2004?
Give a very brief answer. 1.49. What is the ratio of the Emissions(in percent) of United Arab Emirates in 2001 to that in 2004?
Your answer should be very brief. 0.9. What is the ratio of the Emissions(in percent) of Canada in 2001 to that in 2005?
Give a very brief answer. 0.95. What is the ratio of the Emissions(in percent) in Macedonia in 2001 to that in 2005?
Offer a terse response. 1.08. What is the ratio of the Emissions(in percent) in Norway in 2001 to that in 2005?
Provide a short and direct response. 1.47. What is the ratio of the Emissions(in percent) of United Arab Emirates in 2001 to that in 2005?
Offer a terse response. 0.91. What is the ratio of the Emissions(in percent) of Canada in 2002 to that in 2003?
Your answer should be very brief. 0.98. What is the ratio of the Emissions(in percent) in Macedonia in 2002 to that in 2003?
Offer a terse response. 1.19. What is the ratio of the Emissions(in percent) of Norway in 2002 to that in 2003?
Provide a short and direct response. 1.14. What is the ratio of the Emissions(in percent) of United Arab Emirates in 2002 to that in 2003?
Give a very brief answer. 1.21. What is the ratio of the Emissions(in percent) of Canada in 2002 to that in 2004?
Your response must be concise. 1. What is the ratio of the Emissions(in percent) in Macedonia in 2002 to that in 2004?
Give a very brief answer. 1.3. What is the ratio of the Emissions(in percent) in Norway in 2002 to that in 2004?
Keep it short and to the point. 1.14. What is the ratio of the Emissions(in percent) of United Arab Emirates in 2002 to that in 2004?
Keep it short and to the point. 1.21. What is the ratio of the Emissions(in percent) of Canada in 2002 to that in 2005?
Keep it short and to the point. 0.99. What is the ratio of the Emissions(in percent) of Macedonia in 2002 to that in 2005?
Keep it short and to the point. 1.24. What is the ratio of the Emissions(in percent) in Norway in 2002 to that in 2005?
Keep it short and to the point. 1.13. What is the ratio of the Emissions(in percent) of United Arab Emirates in 2002 to that in 2005?
Ensure brevity in your answer.  1.22. What is the ratio of the Emissions(in percent) of Canada in 2003 to that in 2004?
Your answer should be very brief. 1.02. What is the ratio of the Emissions(in percent) in Macedonia in 2003 to that in 2004?
Keep it short and to the point. 1.1. What is the ratio of the Emissions(in percent) of United Arab Emirates in 2003 to that in 2004?
Ensure brevity in your answer.  0.99. What is the ratio of the Emissions(in percent) in Canada in 2003 to that in 2005?
Offer a terse response. 1.01. What is the ratio of the Emissions(in percent) of Macedonia in 2003 to that in 2005?
Offer a terse response. 1.05. What is the ratio of the Emissions(in percent) in Norway in 2003 to that in 2005?
Make the answer very short. 0.99. What is the ratio of the Emissions(in percent) in Canada in 2004 to that in 2005?
Offer a terse response. 0.99. What is the ratio of the Emissions(in percent) in Macedonia in 2004 to that in 2005?
Ensure brevity in your answer.  0.96. What is the ratio of the Emissions(in percent) in United Arab Emirates in 2004 to that in 2005?
Give a very brief answer. 1.01. What is the difference between the highest and the second highest Emissions(in percent) in Canada?
Offer a terse response. 0.22. What is the difference between the highest and the second highest Emissions(in percent) in Macedonia?
Your answer should be very brief. 0.2. What is the difference between the highest and the second highest Emissions(in percent) in Norway?
Provide a succinct answer. 5.1. What is the difference between the highest and the second highest Emissions(in percent) of United Arab Emirates?
Provide a succinct answer. 9.39. What is the difference between the highest and the lowest Emissions(in percent) of Canada?
Give a very brief answer. 1.83. What is the difference between the highest and the lowest Emissions(in percent) in Macedonia?
Keep it short and to the point. 0.92. What is the difference between the highest and the lowest Emissions(in percent) of Norway?
Make the answer very short. 10.7. What is the difference between the highest and the lowest Emissions(in percent) in United Arab Emirates?
Provide a short and direct response. 28.51. 